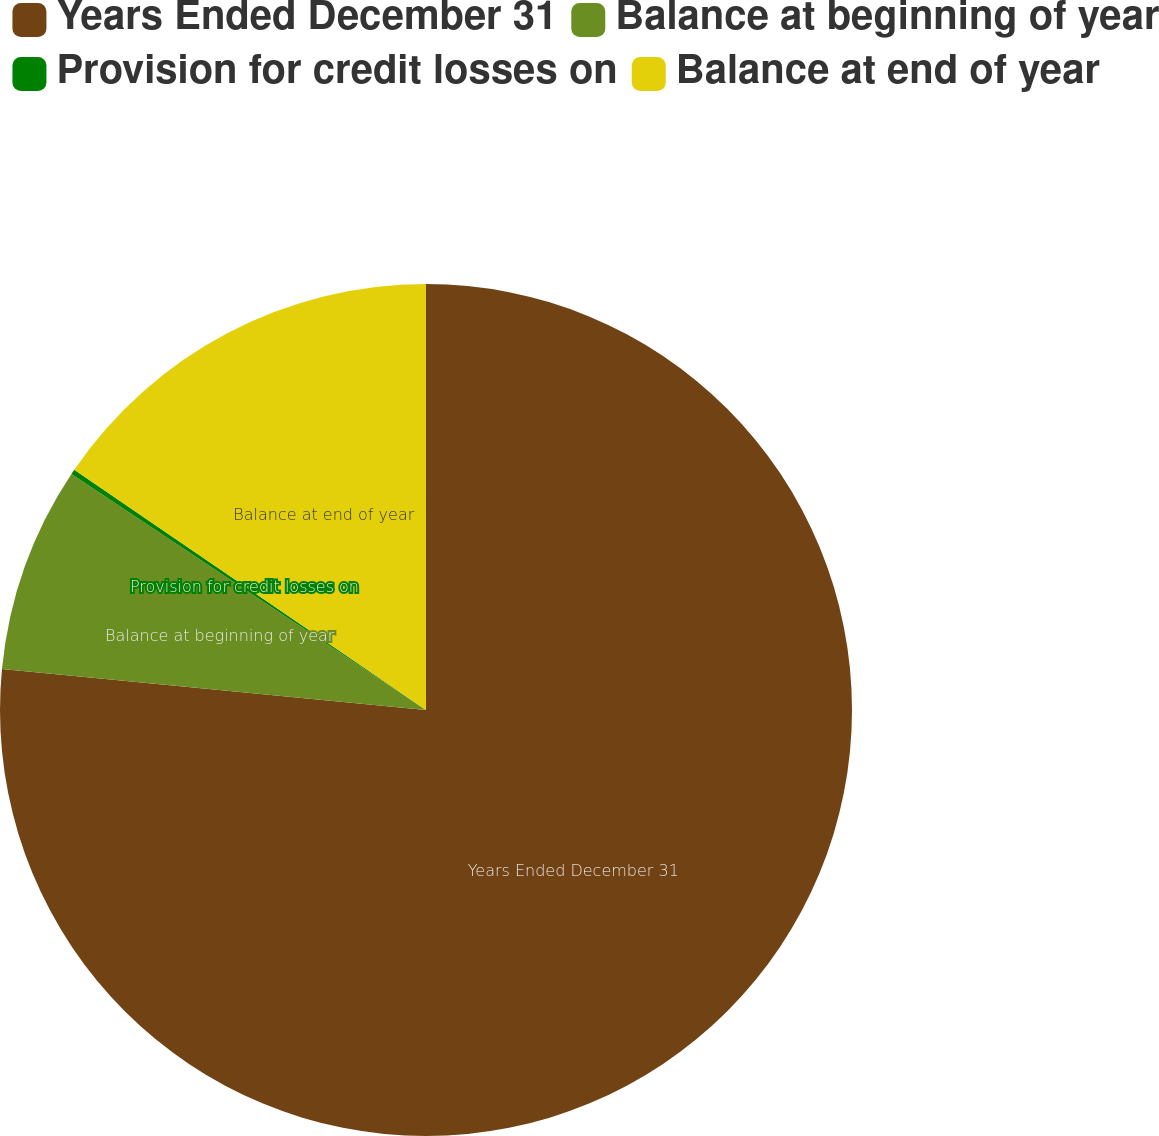Convert chart to OTSL. <chart><loc_0><loc_0><loc_500><loc_500><pie_chart><fcel>Years Ended December 31<fcel>Balance at beginning of year<fcel>Provision for credit losses on<fcel>Balance at end of year<nl><fcel>76.53%<fcel>7.82%<fcel>0.19%<fcel>15.46%<nl></chart> 